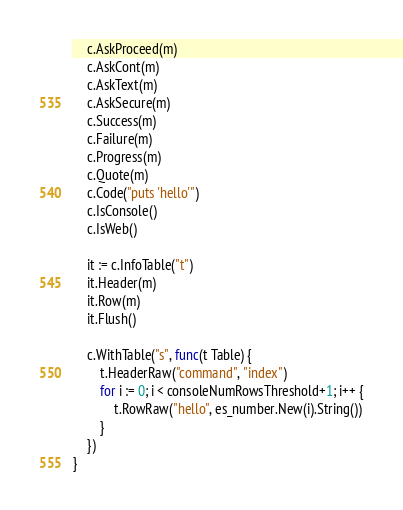Convert code to text. <code><loc_0><loc_0><loc_500><loc_500><_Go_>	c.AskProceed(m)
	c.AskCont(m)
	c.AskText(m)
	c.AskSecure(m)
	c.Success(m)
	c.Failure(m)
	c.Progress(m)
	c.Quote(m)
	c.Code("puts 'hello'")
	c.IsConsole()
	c.IsWeb()

	it := c.InfoTable("t")
	it.Header(m)
	it.Row(m)
	it.Flush()

	c.WithTable("s", func(t Table) {
		t.HeaderRaw("command", "index")
		for i := 0; i < consoleNumRowsThreshold+1; i++ {
			t.RowRaw("hello", es_number.New(i).String())
		}
	})
}
</code> 